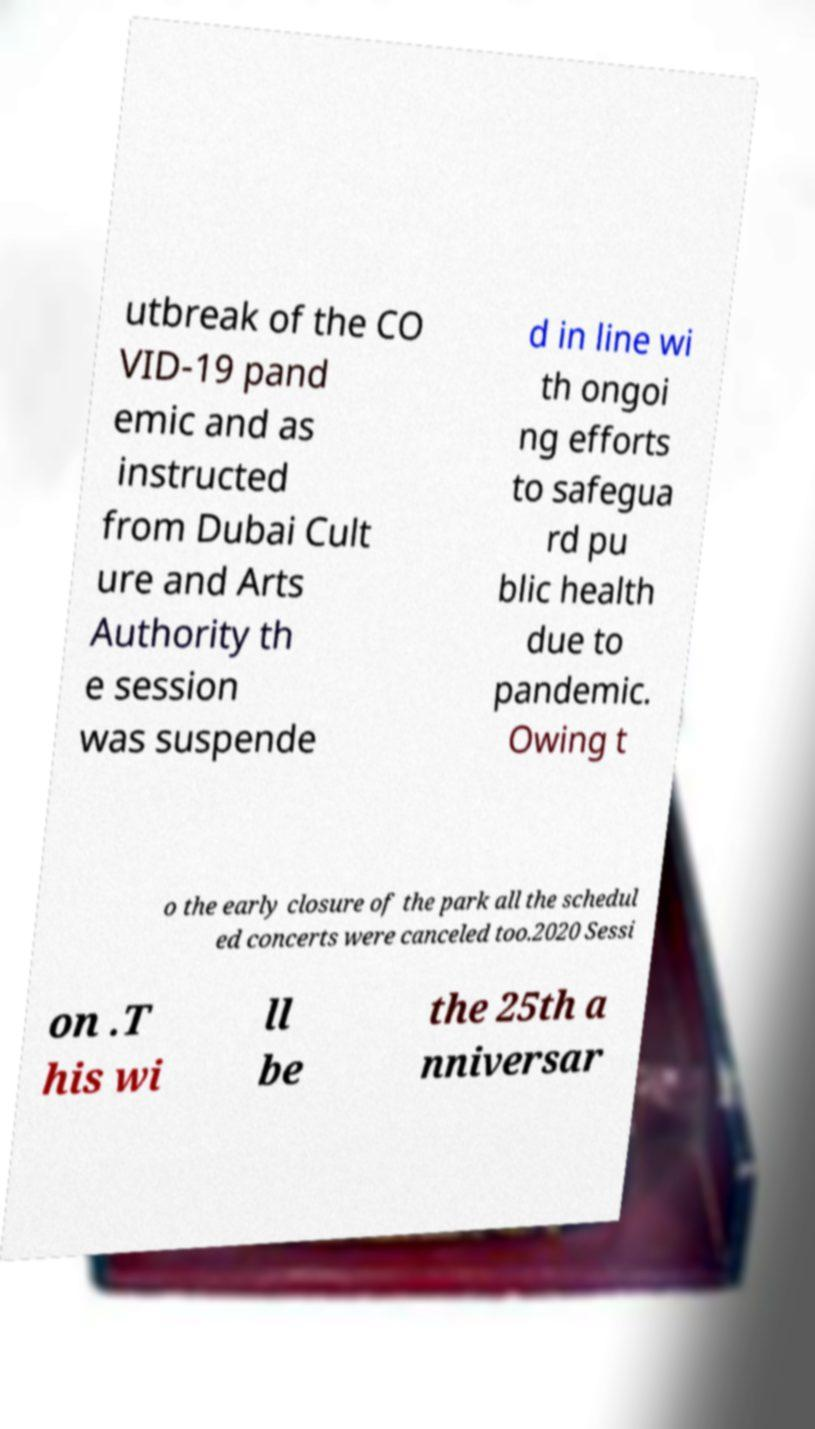Could you extract and type out the text from this image? utbreak of the CO VID-19 pand emic and as instructed from Dubai Cult ure and Arts Authority th e session was suspende d in line wi th ongoi ng efforts to safegua rd pu blic health due to pandemic. Owing t o the early closure of the park all the schedul ed concerts were canceled too.2020 Sessi on .T his wi ll be the 25th a nniversar 